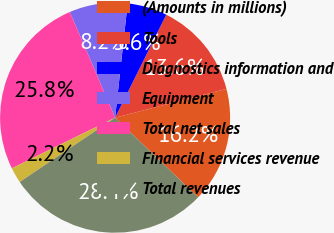Convert chart. <chart><loc_0><loc_0><loc_500><loc_500><pie_chart><fcel>(Amounts in millions)<fcel>Tools<fcel>Diagnostics information and<fcel>Equipment<fcel>Total net sales<fcel>Financial services revenue<fcel>Total revenues<nl><fcel>16.21%<fcel>13.63%<fcel>5.6%<fcel>8.18%<fcel>25.81%<fcel>2.19%<fcel>28.39%<nl></chart> 